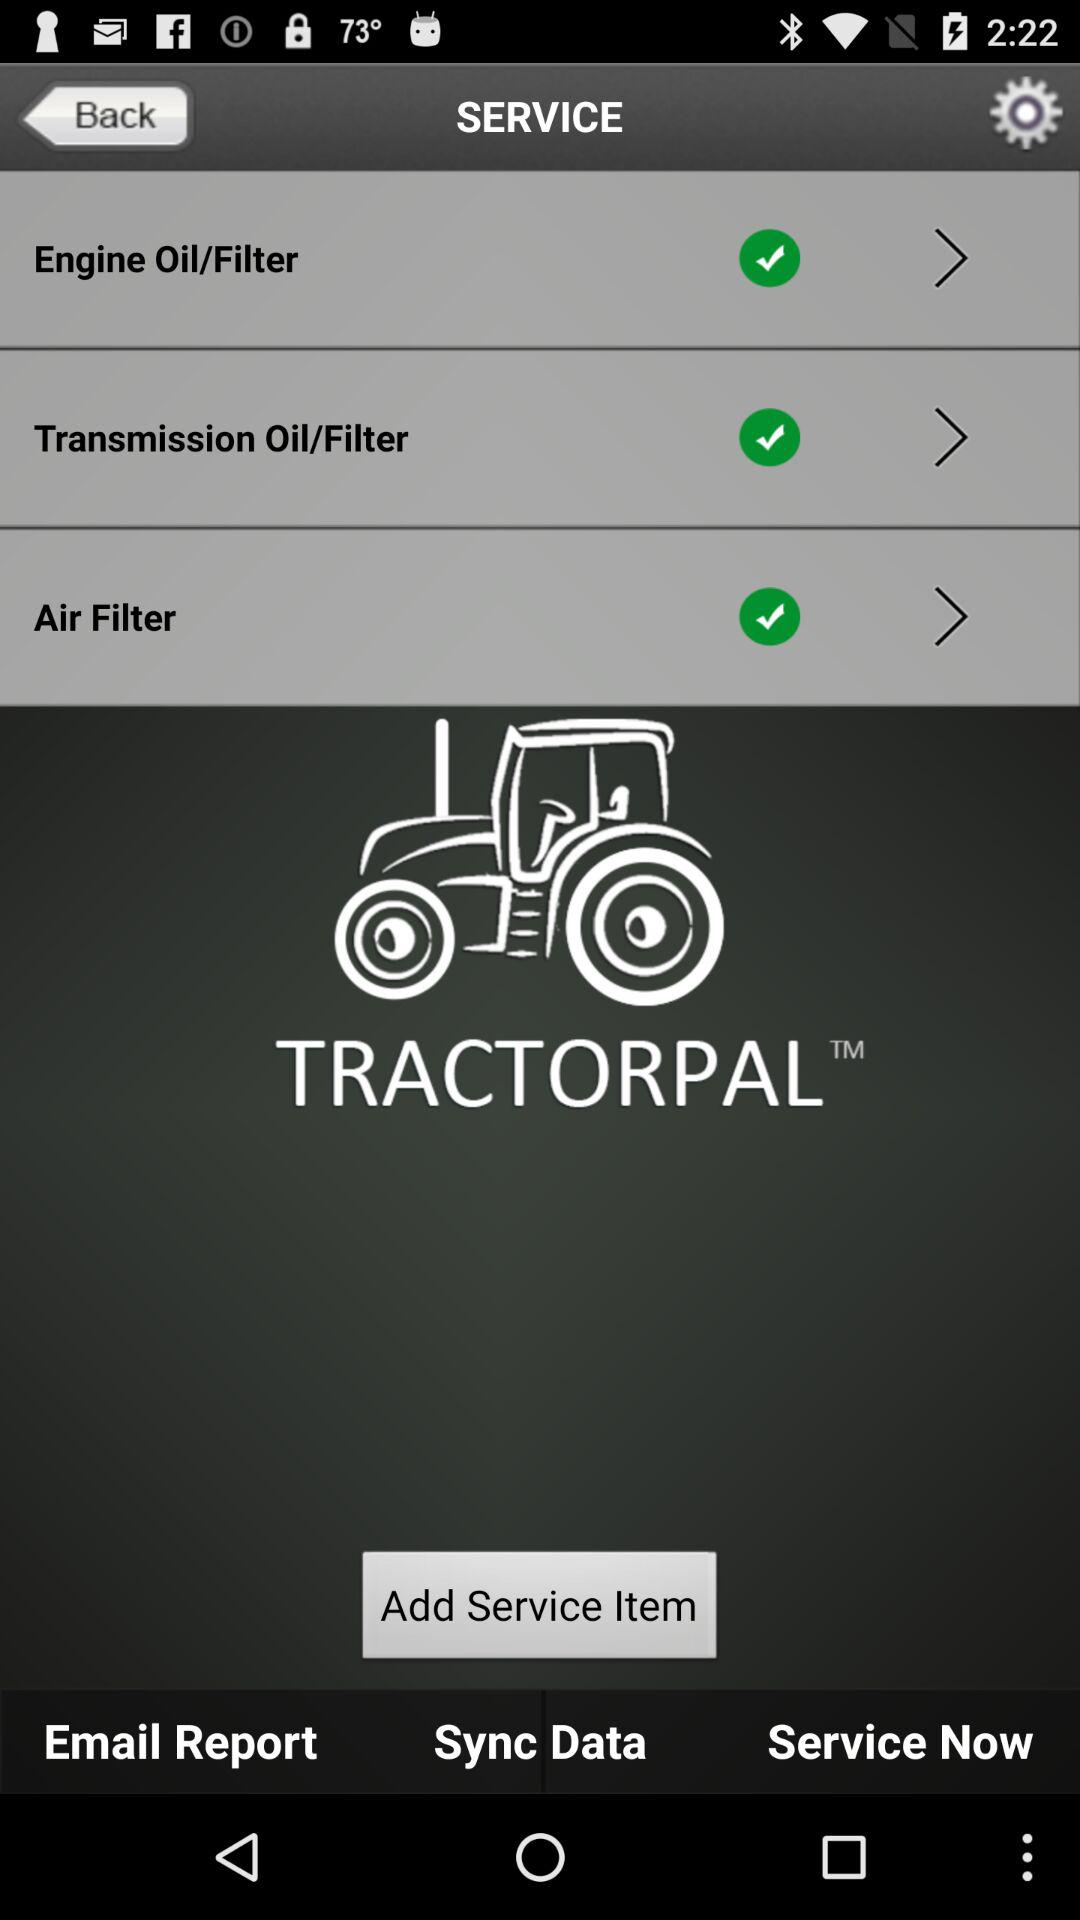How many service items are there?
Answer the question using a single word or phrase. 3 